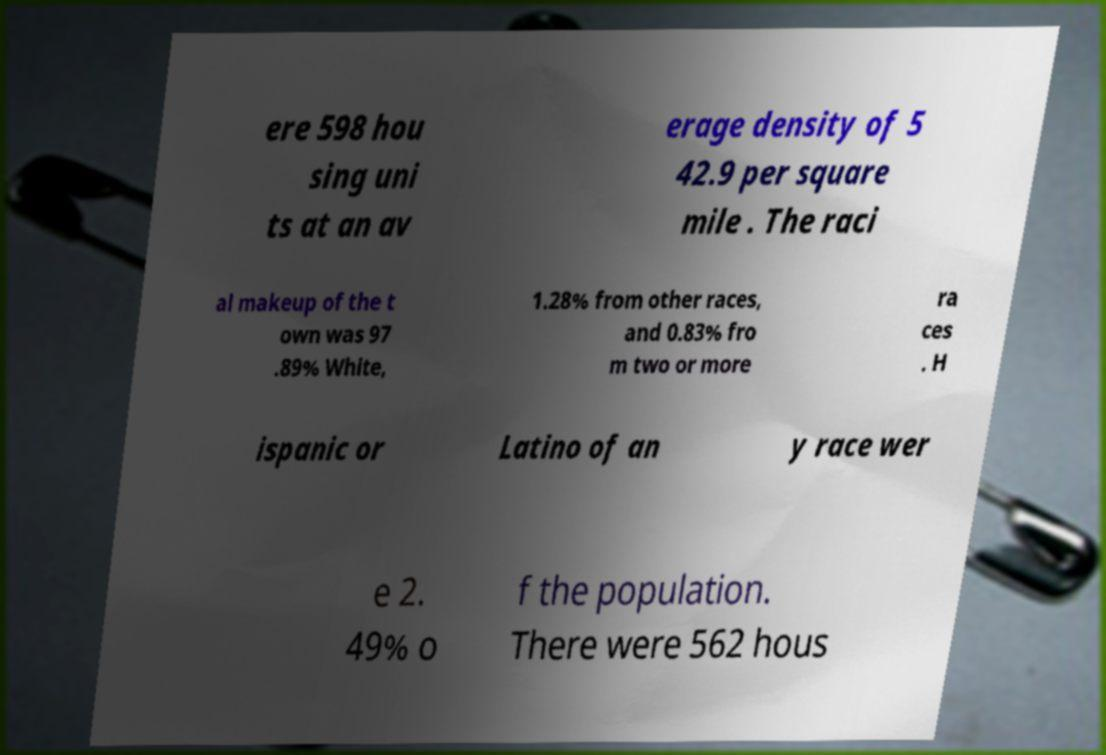Please identify and transcribe the text found in this image. ere 598 hou sing uni ts at an av erage density of 5 42.9 per square mile . The raci al makeup of the t own was 97 .89% White, 1.28% from other races, and 0.83% fro m two or more ra ces . H ispanic or Latino of an y race wer e 2. 49% o f the population. There were 562 hous 